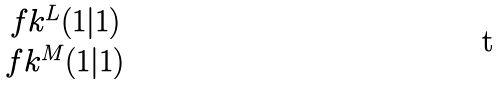<formula> <loc_0><loc_0><loc_500><loc_500>\begin{matrix} \ f k ^ { L } ( 1 | 1 ) \\ \ f k ^ { M } ( 1 | 1 ) \end{matrix}</formula> 